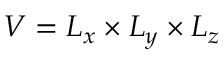Convert formula to latex. <formula><loc_0><loc_0><loc_500><loc_500>V = L _ { x } \times L _ { y } \times L _ { z }</formula> 